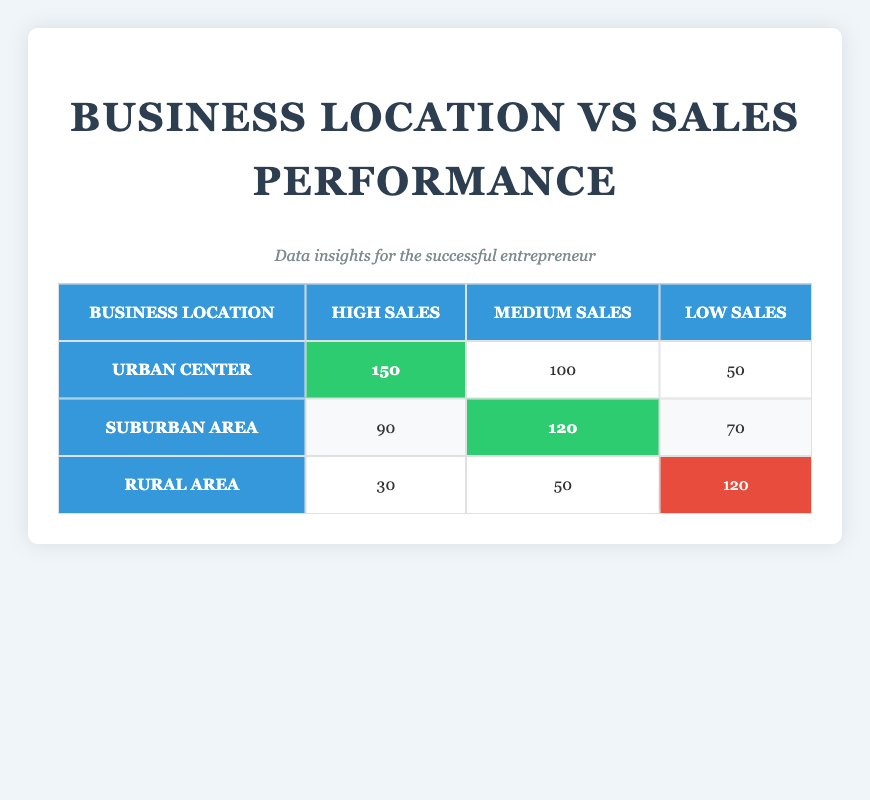What is the highest sales performance location? The highest sales performance is found in the Urban Center, where the High Sales value is 150.
Answer: Urban Center How many total sales were reported for the Suburban Area? To find the total sales for the Suburban Area, we sum the values: 90 (High) + 120 (Medium) + 70 (Low) = 280.
Answer: 280 Is it true that the Rural Area has more Low Sales than the Urban Center? The Rural Area has 120 Low Sales, while the Urban Center has only 50 Low Sales. Therefore, it's true that the Rural Area has more Low Sales.
Answer: Yes What is the average sales performance for the Urban Center? The average sales performance is calculated by summing all sales (150 + 100 + 50 = 300) and then dividing by the number of performance levels (3). Average = 300 / 3 = 100.
Answer: 100 Which location has the lowest Medium Sales performance? The location with the lowest Medium Sales is the Rural Area, with a value of 50 compared to 100 and 120 of Urban Center and Suburban Area, respectively.
Answer: Rural Area What is the difference between High Sales in the Urban Center and Low Sales in the Rural Area? High Sales in the Urban Center is 150, while Low Sales in the Rural Area is 120. The difference is 150 - 120 = 30.
Answer: 30 How do Medium and Low Sales compare in the Suburban Area? Medium Sales in the Suburban Area is 120, while Low Sales is 70. Therefore, Medium Sales are 50 more than Low Sales.
Answer: Medium Sales are higher by 50 Do any of the locations have the same Low Sales performance? The Low Sales for the Urban Center is 50, Suburban Area is 70, and Rural Area is 120. None of them share the same value, so the statement is false.
Answer: No 